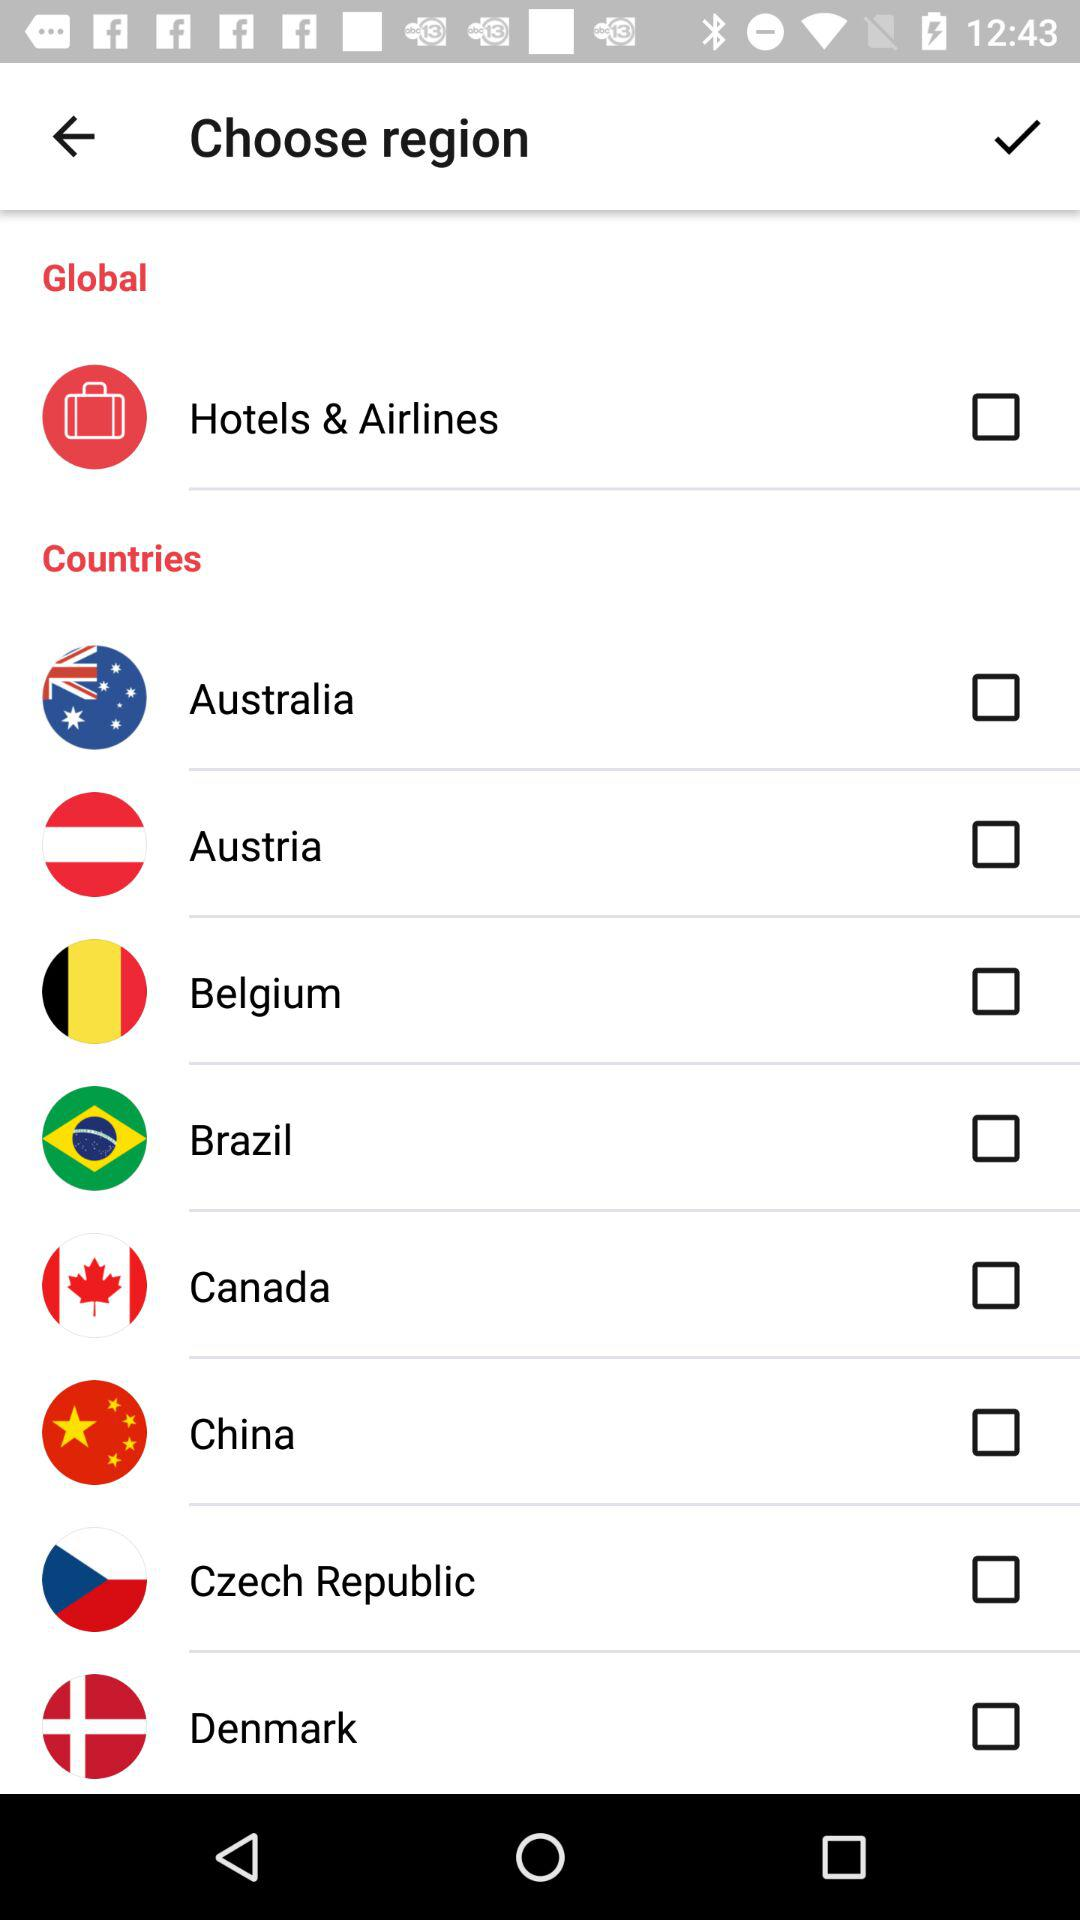What are the names of countries? The countries are Australia, Austria, Belgium, Brazil, Canada, China, the Czech Republic, and Denmark. 